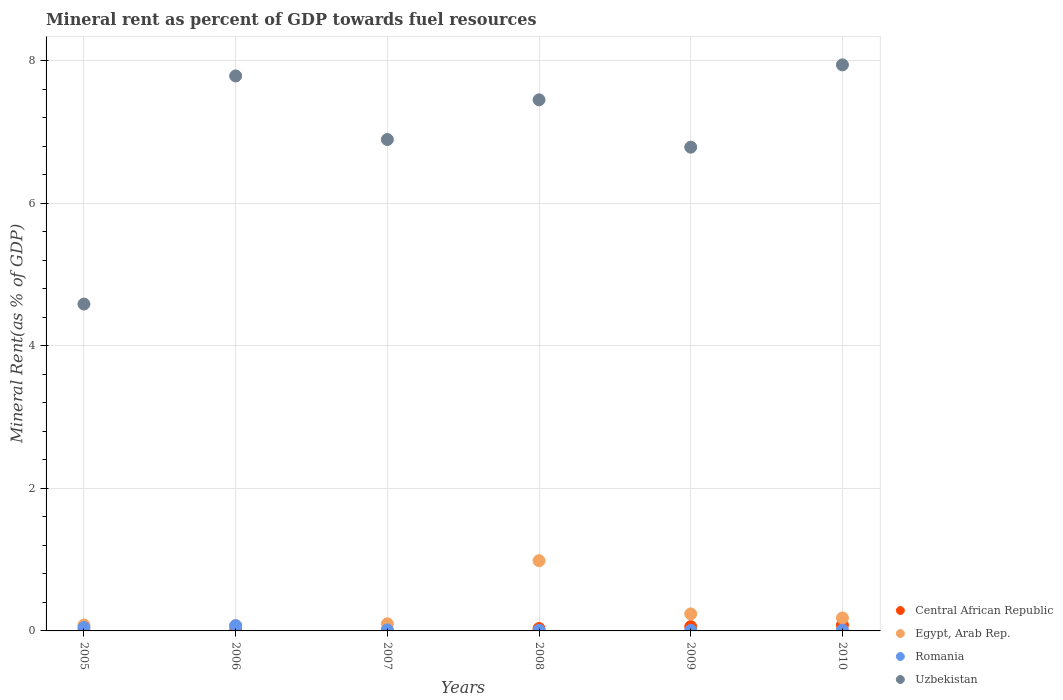How many different coloured dotlines are there?
Provide a short and direct response. 4. What is the mineral rent in Uzbekistan in 2005?
Provide a succinct answer. 4.59. Across all years, what is the maximum mineral rent in Uzbekistan?
Offer a terse response. 7.95. Across all years, what is the minimum mineral rent in Uzbekistan?
Provide a succinct answer. 4.59. In which year was the mineral rent in Central African Republic maximum?
Your answer should be very brief. 2010. In which year was the mineral rent in Central African Republic minimum?
Offer a very short reply. 2005. What is the total mineral rent in Egypt, Arab Rep. in the graph?
Make the answer very short. 1.67. What is the difference between the mineral rent in Egypt, Arab Rep. in 2005 and that in 2009?
Your answer should be compact. -0.16. What is the difference between the mineral rent in Egypt, Arab Rep. in 2005 and the mineral rent in Uzbekistan in 2008?
Offer a terse response. -7.37. What is the average mineral rent in Romania per year?
Offer a terse response. 0.03. In the year 2009, what is the difference between the mineral rent in Romania and mineral rent in Uzbekistan?
Give a very brief answer. -6.78. In how many years, is the mineral rent in Egypt, Arab Rep. greater than 7.6 %?
Your answer should be compact. 0. What is the ratio of the mineral rent in Uzbekistan in 2005 to that in 2009?
Your response must be concise. 0.68. Is the difference between the mineral rent in Romania in 2008 and 2009 greater than the difference between the mineral rent in Uzbekistan in 2008 and 2009?
Offer a terse response. No. What is the difference between the highest and the second highest mineral rent in Central African Republic?
Make the answer very short. 0.02. What is the difference between the highest and the lowest mineral rent in Egypt, Arab Rep.?
Offer a very short reply. 0.91. Is the sum of the mineral rent in Egypt, Arab Rep. in 2007 and 2008 greater than the maximum mineral rent in Uzbekistan across all years?
Give a very brief answer. No. Is it the case that in every year, the sum of the mineral rent in Romania and mineral rent in Uzbekistan  is greater than the mineral rent in Central African Republic?
Offer a terse response. Yes. Does the mineral rent in Central African Republic monotonically increase over the years?
Provide a short and direct response. Yes. Is the mineral rent in Central African Republic strictly greater than the mineral rent in Uzbekistan over the years?
Your answer should be very brief. No. Is the mineral rent in Egypt, Arab Rep. strictly less than the mineral rent in Romania over the years?
Give a very brief answer. No. How many years are there in the graph?
Offer a terse response. 6. What is the difference between two consecutive major ticks on the Y-axis?
Provide a short and direct response. 2. Are the values on the major ticks of Y-axis written in scientific E-notation?
Keep it short and to the point. No. Does the graph contain any zero values?
Provide a short and direct response. No. Does the graph contain grids?
Provide a succinct answer. Yes. Where does the legend appear in the graph?
Your response must be concise. Bottom right. How are the legend labels stacked?
Keep it short and to the point. Vertical. What is the title of the graph?
Keep it short and to the point. Mineral rent as percent of GDP towards fuel resources. Does "Cabo Verde" appear as one of the legend labels in the graph?
Provide a succinct answer. No. What is the label or title of the X-axis?
Your answer should be compact. Years. What is the label or title of the Y-axis?
Your response must be concise. Mineral Rent(as % of GDP). What is the Mineral Rent(as % of GDP) of Central African Republic in 2005?
Provide a short and direct response. 0. What is the Mineral Rent(as % of GDP) of Egypt, Arab Rep. in 2005?
Give a very brief answer. 0.08. What is the Mineral Rent(as % of GDP) of Romania in 2005?
Provide a short and direct response. 0.05. What is the Mineral Rent(as % of GDP) in Uzbekistan in 2005?
Give a very brief answer. 4.59. What is the Mineral Rent(as % of GDP) in Central African Republic in 2006?
Your response must be concise. 0.01. What is the Mineral Rent(as % of GDP) of Egypt, Arab Rep. in 2006?
Make the answer very short. 0.08. What is the Mineral Rent(as % of GDP) in Romania in 2006?
Provide a short and direct response. 0.07. What is the Mineral Rent(as % of GDP) in Uzbekistan in 2006?
Your answer should be very brief. 7.79. What is the Mineral Rent(as % of GDP) of Central African Republic in 2007?
Offer a very short reply. 0.01. What is the Mineral Rent(as % of GDP) of Egypt, Arab Rep. in 2007?
Provide a short and direct response. 0.1. What is the Mineral Rent(as % of GDP) in Romania in 2007?
Make the answer very short. 0.01. What is the Mineral Rent(as % of GDP) of Uzbekistan in 2007?
Offer a very short reply. 6.9. What is the Mineral Rent(as % of GDP) of Central African Republic in 2008?
Your answer should be very brief. 0.03. What is the Mineral Rent(as % of GDP) of Egypt, Arab Rep. in 2008?
Provide a succinct answer. 0.99. What is the Mineral Rent(as % of GDP) in Romania in 2008?
Your answer should be very brief. 0.01. What is the Mineral Rent(as % of GDP) in Uzbekistan in 2008?
Offer a terse response. 7.45. What is the Mineral Rent(as % of GDP) in Central African Republic in 2009?
Your answer should be very brief. 0.06. What is the Mineral Rent(as % of GDP) of Egypt, Arab Rep. in 2009?
Your answer should be very brief. 0.24. What is the Mineral Rent(as % of GDP) of Romania in 2009?
Make the answer very short. 0.01. What is the Mineral Rent(as % of GDP) in Uzbekistan in 2009?
Offer a very short reply. 6.79. What is the Mineral Rent(as % of GDP) in Central African Republic in 2010?
Make the answer very short. 0.08. What is the Mineral Rent(as % of GDP) of Egypt, Arab Rep. in 2010?
Your answer should be compact. 0.18. What is the Mineral Rent(as % of GDP) in Romania in 2010?
Your answer should be compact. 0.01. What is the Mineral Rent(as % of GDP) in Uzbekistan in 2010?
Keep it short and to the point. 7.95. Across all years, what is the maximum Mineral Rent(as % of GDP) of Central African Republic?
Offer a terse response. 0.08. Across all years, what is the maximum Mineral Rent(as % of GDP) in Egypt, Arab Rep.?
Provide a short and direct response. 0.99. Across all years, what is the maximum Mineral Rent(as % of GDP) in Romania?
Your answer should be compact. 0.07. Across all years, what is the maximum Mineral Rent(as % of GDP) of Uzbekistan?
Provide a short and direct response. 7.95. Across all years, what is the minimum Mineral Rent(as % of GDP) in Central African Republic?
Ensure brevity in your answer.  0. Across all years, what is the minimum Mineral Rent(as % of GDP) in Egypt, Arab Rep.?
Your answer should be compact. 0.08. Across all years, what is the minimum Mineral Rent(as % of GDP) in Romania?
Make the answer very short. 0.01. Across all years, what is the minimum Mineral Rent(as % of GDP) of Uzbekistan?
Provide a succinct answer. 4.59. What is the total Mineral Rent(as % of GDP) of Central African Republic in the graph?
Your response must be concise. 0.19. What is the total Mineral Rent(as % of GDP) in Egypt, Arab Rep. in the graph?
Ensure brevity in your answer.  1.67. What is the total Mineral Rent(as % of GDP) in Romania in the graph?
Your response must be concise. 0.16. What is the total Mineral Rent(as % of GDP) of Uzbekistan in the graph?
Make the answer very short. 41.47. What is the difference between the Mineral Rent(as % of GDP) of Central African Republic in 2005 and that in 2006?
Give a very brief answer. -0. What is the difference between the Mineral Rent(as % of GDP) of Egypt, Arab Rep. in 2005 and that in 2006?
Offer a very short reply. 0.01. What is the difference between the Mineral Rent(as % of GDP) in Romania in 2005 and that in 2006?
Provide a succinct answer. -0.03. What is the difference between the Mineral Rent(as % of GDP) of Uzbekistan in 2005 and that in 2006?
Provide a succinct answer. -3.2. What is the difference between the Mineral Rent(as % of GDP) of Central African Republic in 2005 and that in 2007?
Make the answer very short. -0. What is the difference between the Mineral Rent(as % of GDP) in Egypt, Arab Rep. in 2005 and that in 2007?
Make the answer very short. -0.02. What is the difference between the Mineral Rent(as % of GDP) of Romania in 2005 and that in 2007?
Offer a very short reply. 0.03. What is the difference between the Mineral Rent(as % of GDP) in Uzbekistan in 2005 and that in 2007?
Keep it short and to the point. -2.31. What is the difference between the Mineral Rent(as % of GDP) in Central African Republic in 2005 and that in 2008?
Your answer should be very brief. -0.03. What is the difference between the Mineral Rent(as % of GDP) of Egypt, Arab Rep. in 2005 and that in 2008?
Offer a terse response. -0.9. What is the difference between the Mineral Rent(as % of GDP) in Romania in 2005 and that in 2008?
Your answer should be compact. 0.04. What is the difference between the Mineral Rent(as % of GDP) in Uzbekistan in 2005 and that in 2008?
Provide a short and direct response. -2.87. What is the difference between the Mineral Rent(as % of GDP) of Central African Republic in 2005 and that in 2009?
Your response must be concise. -0.06. What is the difference between the Mineral Rent(as % of GDP) of Egypt, Arab Rep. in 2005 and that in 2009?
Your answer should be compact. -0.16. What is the difference between the Mineral Rent(as % of GDP) of Romania in 2005 and that in 2009?
Offer a terse response. 0.04. What is the difference between the Mineral Rent(as % of GDP) in Uzbekistan in 2005 and that in 2009?
Keep it short and to the point. -2.2. What is the difference between the Mineral Rent(as % of GDP) of Central African Republic in 2005 and that in 2010?
Offer a terse response. -0.08. What is the difference between the Mineral Rent(as % of GDP) in Egypt, Arab Rep. in 2005 and that in 2010?
Offer a very short reply. -0.1. What is the difference between the Mineral Rent(as % of GDP) of Romania in 2005 and that in 2010?
Provide a succinct answer. 0.04. What is the difference between the Mineral Rent(as % of GDP) of Uzbekistan in 2005 and that in 2010?
Your response must be concise. -3.36. What is the difference between the Mineral Rent(as % of GDP) of Central African Republic in 2006 and that in 2007?
Make the answer very short. -0. What is the difference between the Mineral Rent(as % of GDP) in Egypt, Arab Rep. in 2006 and that in 2007?
Keep it short and to the point. -0.02. What is the difference between the Mineral Rent(as % of GDP) in Romania in 2006 and that in 2007?
Ensure brevity in your answer.  0.06. What is the difference between the Mineral Rent(as % of GDP) in Uzbekistan in 2006 and that in 2007?
Offer a very short reply. 0.89. What is the difference between the Mineral Rent(as % of GDP) of Central African Republic in 2006 and that in 2008?
Provide a succinct answer. -0.03. What is the difference between the Mineral Rent(as % of GDP) in Egypt, Arab Rep. in 2006 and that in 2008?
Ensure brevity in your answer.  -0.91. What is the difference between the Mineral Rent(as % of GDP) in Romania in 2006 and that in 2008?
Make the answer very short. 0.07. What is the difference between the Mineral Rent(as % of GDP) of Uzbekistan in 2006 and that in 2008?
Your answer should be very brief. 0.34. What is the difference between the Mineral Rent(as % of GDP) in Central African Republic in 2006 and that in 2009?
Give a very brief answer. -0.05. What is the difference between the Mineral Rent(as % of GDP) of Egypt, Arab Rep. in 2006 and that in 2009?
Keep it short and to the point. -0.16. What is the difference between the Mineral Rent(as % of GDP) of Romania in 2006 and that in 2009?
Make the answer very short. 0.07. What is the difference between the Mineral Rent(as % of GDP) in Uzbekistan in 2006 and that in 2009?
Give a very brief answer. 1. What is the difference between the Mineral Rent(as % of GDP) in Central African Republic in 2006 and that in 2010?
Ensure brevity in your answer.  -0.08. What is the difference between the Mineral Rent(as % of GDP) in Egypt, Arab Rep. in 2006 and that in 2010?
Your answer should be compact. -0.11. What is the difference between the Mineral Rent(as % of GDP) of Romania in 2006 and that in 2010?
Offer a terse response. 0.06. What is the difference between the Mineral Rent(as % of GDP) in Uzbekistan in 2006 and that in 2010?
Ensure brevity in your answer.  -0.16. What is the difference between the Mineral Rent(as % of GDP) in Central African Republic in 2007 and that in 2008?
Offer a very short reply. -0.03. What is the difference between the Mineral Rent(as % of GDP) of Egypt, Arab Rep. in 2007 and that in 2008?
Offer a very short reply. -0.89. What is the difference between the Mineral Rent(as % of GDP) in Romania in 2007 and that in 2008?
Provide a short and direct response. 0.01. What is the difference between the Mineral Rent(as % of GDP) in Uzbekistan in 2007 and that in 2008?
Make the answer very short. -0.56. What is the difference between the Mineral Rent(as % of GDP) in Central African Republic in 2007 and that in 2009?
Provide a succinct answer. -0.05. What is the difference between the Mineral Rent(as % of GDP) in Egypt, Arab Rep. in 2007 and that in 2009?
Make the answer very short. -0.14. What is the difference between the Mineral Rent(as % of GDP) of Romania in 2007 and that in 2009?
Provide a succinct answer. 0.01. What is the difference between the Mineral Rent(as % of GDP) of Uzbekistan in 2007 and that in 2009?
Make the answer very short. 0.11. What is the difference between the Mineral Rent(as % of GDP) in Central African Republic in 2007 and that in 2010?
Your answer should be compact. -0.08. What is the difference between the Mineral Rent(as % of GDP) in Egypt, Arab Rep. in 2007 and that in 2010?
Provide a short and direct response. -0.08. What is the difference between the Mineral Rent(as % of GDP) of Romania in 2007 and that in 2010?
Offer a very short reply. 0. What is the difference between the Mineral Rent(as % of GDP) of Uzbekistan in 2007 and that in 2010?
Your answer should be very brief. -1.05. What is the difference between the Mineral Rent(as % of GDP) in Central African Republic in 2008 and that in 2009?
Give a very brief answer. -0.03. What is the difference between the Mineral Rent(as % of GDP) of Egypt, Arab Rep. in 2008 and that in 2009?
Your answer should be very brief. 0.75. What is the difference between the Mineral Rent(as % of GDP) of Romania in 2008 and that in 2009?
Your answer should be very brief. 0. What is the difference between the Mineral Rent(as % of GDP) of Uzbekistan in 2008 and that in 2009?
Keep it short and to the point. 0.66. What is the difference between the Mineral Rent(as % of GDP) of Central African Republic in 2008 and that in 2010?
Provide a short and direct response. -0.05. What is the difference between the Mineral Rent(as % of GDP) of Egypt, Arab Rep. in 2008 and that in 2010?
Your response must be concise. 0.8. What is the difference between the Mineral Rent(as % of GDP) in Romania in 2008 and that in 2010?
Make the answer very short. -0. What is the difference between the Mineral Rent(as % of GDP) of Uzbekistan in 2008 and that in 2010?
Your response must be concise. -0.49. What is the difference between the Mineral Rent(as % of GDP) in Central African Republic in 2009 and that in 2010?
Your response must be concise. -0.02. What is the difference between the Mineral Rent(as % of GDP) in Egypt, Arab Rep. in 2009 and that in 2010?
Keep it short and to the point. 0.06. What is the difference between the Mineral Rent(as % of GDP) of Romania in 2009 and that in 2010?
Provide a short and direct response. -0. What is the difference between the Mineral Rent(as % of GDP) of Uzbekistan in 2009 and that in 2010?
Provide a short and direct response. -1.16. What is the difference between the Mineral Rent(as % of GDP) in Central African Republic in 2005 and the Mineral Rent(as % of GDP) in Egypt, Arab Rep. in 2006?
Offer a very short reply. -0.07. What is the difference between the Mineral Rent(as % of GDP) in Central African Republic in 2005 and the Mineral Rent(as % of GDP) in Romania in 2006?
Your answer should be compact. -0.07. What is the difference between the Mineral Rent(as % of GDP) of Central African Republic in 2005 and the Mineral Rent(as % of GDP) of Uzbekistan in 2006?
Offer a very short reply. -7.79. What is the difference between the Mineral Rent(as % of GDP) in Egypt, Arab Rep. in 2005 and the Mineral Rent(as % of GDP) in Romania in 2006?
Offer a terse response. 0.01. What is the difference between the Mineral Rent(as % of GDP) of Egypt, Arab Rep. in 2005 and the Mineral Rent(as % of GDP) of Uzbekistan in 2006?
Ensure brevity in your answer.  -7.71. What is the difference between the Mineral Rent(as % of GDP) in Romania in 2005 and the Mineral Rent(as % of GDP) in Uzbekistan in 2006?
Make the answer very short. -7.74. What is the difference between the Mineral Rent(as % of GDP) in Central African Republic in 2005 and the Mineral Rent(as % of GDP) in Egypt, Arab Rep. in 2007?
Provide a succinct answer. -0.1. What is the difference between the Mineral Rent(as % of GDP) in Central African Republic in 2005 and the Mineral Rent(as % of GDP) in Romania in 2007?
Ensure brevity in your answer.  -0.01. What is the difference between the Mineral Rent(as % of GDP) of Central African Republic in 2005 and the Mineral Rent(as % of GDP) of Uzbekistan in 2007?
Provide a succinct answer. -6.89. What is the difference between the Mineral Rent(as % of GDP) in Egypt, Arab Rep. in 2005 and the Mineral Rent(as % of GDP) in Romania in 2007?
Provide a short and direct response. 0.07. What is the difference between the Mineral Rent(as % of GDP) in Egypt, Arab Rep. in 2005 and the Mineral Rent(as % of GDP) in Uzbekistan in 2007?
Offer a very short reply. -6.81. What is the difference between the Mineral Rent(as % of GDP) of Romania in 2005 and the Mineral Rent(as % of GDP) of Uzbekistan in 2007?
Keep it short and to the point. -6.85. What is the difference between the Mineral Rent(as % of GDP) of Central African Republic in 2005 and the Mineral Rent(as % of GDP) of Egypt, Arab Rep. in 2008?
Give a very brief answer. -0.98. What is the difference between the Mineral Rent(as % of GDP) of Central African Republic in 2005 and the Mineral Rent(as % of GDP) of Romania in 2008?
Offer a terse response. -0. What is the difference between the Mineral Rent(as % of GDP) of Central African Republic in 2005 and the Mineral Rent(as % of GDP) of Uzbekistan in 2008?
Keep it short and to the point. -7.45. What is the difference between the Mineral Rent(as % of GDP) of Egypt, Arab Rep. in 2005 and the Mineral Rent(as % of GDP) of Romania in 2008?
Give a very brief answer. 0.07. What is the difference between the Mineral Rent(as % of GDP) in Egypt, Arab Rep. in 2005 and the Mineral Rent(as % of GDP) in Uzbekistan in 2008?
Your answer should be compact. -7.37. What is the difference between the Mineral Rent(as % of GDP) of Romania in 2005 and the Mineral Rent(as % of GDP) of Uzbekistan in 2008?
Your answer should be compact. -7.41. What is the difference between the Mineral Rent(as % of GDP) of Central African Republic in 2005 and the Mineral Rent(as % of GDP) of Egypt, Arab Rep. in 2009?
Your answer should be compact. -0.23. What is the difference between the Mineral Rent(as % of GDP) of Central African Republic in 2005 and the Mineral Rent(as % of GDP) of Romania in 2009?
Provide a succinct answer. -0. What is the difference between the Mineral Rent(as % of GDP) in Central African Republic in 2005 and the Mineral Rent(as % of GDP) in Uzbekistan in 2009?
Your response must be concise. -6.79. What is the difference between the Mineral Rent(as % of GDP) in Egypt, Arab Rep. in 2005 and the Mineral Rent(as % of GDP) in Romania in 2009?
Provide a short and direct response. 0.08. What is the difference between the Mineral Rent(as % of GDP) of Egypt, Arab Rep. in 2005 and the Mineral Rent(as % of GDP) of Uzbekistan in 2009?
Make the answer very short. -6.71. What is the difference between the Mineral Rent(as % of GDP) in Romania in 2005 and the Mineral Rent(as % of GDP) in Uzbekistan in 2009?
Offer a very short reply. -6.74. What is the difference between the Mineral Rent(as % of GDP) of Central African Republic in 2005 and the Mineral Rent(as % of GDP) of Egypt, Arab Rep. in 2010?
Give a very brief answer. -0.18. What is the difference between the Mineral Rent(as % of GDP) of Central African Republic in 2005 and the Mineral Rent(as % of GDP) of Romania in 2010?
Provide a succinct answer. -0.01. What is the difference between the Mineral Rent(as % of GDP) of Central African Republic in 2005 and the Mineral Rent(as % of GDP) of Uzbekistan in 2010?
Provide a succinct answer. -7.94. What is the difference between the Mineral Rent(as % of GDP) in Egypt, Arab Rep. in 2005 and the Mineral Rent(as % of GDP) in Romania in 2010?
Your answer should be compact. 0.07. What is the difference between the Mineral Rent(as % of GDP) in Egypt, Arab Rep. in 2005 and the Mineral Rent(as % of GDP) in Uzbekistan in 2010?
Your answer should be very brief. -7.86. What is the difference between the Mineral Rent(as % of GDP) of Romania in 2005 and the Mineral Rent(as % of GDP) of Uzbekistan in 2010?
Your response must be concise. -7.9. What is the difference between the Mineral Rent(as % of GDP) of Central African Republic in 2006 and the Mineral Rent(as % of GDP) of Egypt, Arab Rep. in 2007?
Keep it short and to the point. -0.09. What is the difference between the Mineral Rent(as % of GDP) of Central African Republic in 2006 and the Mineral Rent(as % of GDP) of Romania in 2007?
Your answer should be very brief. -0.01. What is the difference between the Mineral Rent(as % of GDP) in Central African Republic in 2006 and the Mineral Rent(as % of GDP) in Uzbekistan in 2007?
Offer a terse response. -6.89. What is the difference between the Mineral Rent(as % of GDP) in Egypt, Arab Rep. in 2006 and the Mineral Rent(as % of GDP) in Romania in 2007?
Your response must be concise. 0.06. What is the difference between the Mineral Rent(as % of GDP) in Egypt, Arab Rep. in 2006 and the Mineral Rent(as % of GDP) in Uzbekistan in 2007?
Provide a succinct answer. -6.82. What is the difference between the Mineral Rent(as % of GDP) in Romania in 2006 and the Mineral Rent(as % of GDP) in Uzbekistan in 2007?
Give a very brief answer. -6.82. What is the difference between the Mineral Rent(as % of GDP) of Central African Republic in 2006 and the Mineral Rent(as % of GDP) of Egypt, Arab Rep. in 2008?
Give a very brief answer. -0.98. What is the difference between the Mineral Rent(as % of GDP) in Central African Republic in 2006 and the Mineral Rent(as % of GDP) in Romania in 2008?
Provide a succinct answer. -0. What is the difference between the Mineral Rent(as % of GDP) of Central African Republic in 2006 and the Mineral Rent(as % of GDP) of Uzbekistan in 2008?
Provide a succinct answer. -7.45. What is the difference between the Mineral Rent(as % of GDP) of Egypt, Arab Rep. in 2006 and the Mineral Rent(as % of GDP) of Romania in 2008?
Provide a succinct answer. 0.07. What is the difference between the Mineral Rent(as % of GDP) in Egypt, Arab Rep. in 2006 and the Mineral Rent(as % of GDP) in Uzbekistan in 2008?
Your response must be concise. -7.38. What is the difference between the Mineral Rent(as % of GDP) in Romania in 2006 and the Mineral Rent(as % of GDP) in Uzbekistan in 2008?
Offer a terse response. -7.38. What is the difference between the Mineral Rent(as % of GDP) of Central African Republic in 2006 and the Mineral Rent(as % of GDP) of Egypt, Arab Rep. in 2009?
Your answer should be very brief. -0.23. What is the difference between the Mineral Rent(as % of GDP) in Central African Republic in 2006 and the Mineral Rent(as % of GDP) in Romania in 2009?
Give a very brief answer. -0. What is the difference between the Mineral Rent(as % of GDP) of Central African Republic in 2006 and the Mineral Rent(as % of GDP) of Uzbekistan in 2009?
Offer a very short reply. -6.78. What is the difference between the Mineral Rent(as % of GDP) in Egypt, Arab Rep. in 2006 and the Mineral Rent(as % of GDP) in Romania in 2009?
Your response must be concise. 0.07. What is the difference between the Mineral Rent(as % of GDP) of Egypt, Arab Rep. in 2006 and the Mineral Rent(as % of GDP) of Uzbekistan in 2009?
Offer a very short reply. -6.71. What is the difference between the Mineral Rent(as % of GDP) in Romania in 2006 and the Mineral Rent(as % of GDP) in Uzbekistan in 2009?
Offer a terse response. -6.72. What is the difference between the Mineral Rent(as % of GDP) of Central African Republic in 2006 and the Mineral Rent(as % of GDP) of Egypt, Arab Rep. in 2010?
Offer a very short reply. -0.18. What is the difference between the Mineral Rent(as % of GDP) of Central African Republic in 2006 and the Mineral Rent(as % of GDP) of Romania in 2010?
Your response must be concise. -0. What is the difference between the Mineral Rent(as % of GDP) in Central African Republic in 2006 and the Mineral Rent(as % of GDP) in Uzbekistan in 2010?
Your response must be concise. -7.94. What is the difference between the Mineral Rent(as % of GDP) of Egypt, Arab Rep. in 2006 and the Mineral Rent(as % of GDP) of Romania in 2010?
Your answer should be very brief. 0.07. What is the difference between the Mineral Rent(as % of GDP) of Egypt, Arab Rep. in 2006 and the Mineral Rent(as % of GDP) of Uzbekistan in 2010?
Your answer should be very brief. -7.87. What is the difference between the Mineral Rent(as % of GDP) in Romania in 2006 and the Mineral Rent(as % of GDP) in Uzbekistan in 2010?
Give a very brief answer. -7.87. What is the difference between the Mineral Rent(as % of GDP) of Central African Republic in 2007 and the Mineral Rent(as % of GDP) of Egypt, Arab Rep. in 2008?
Offer a very short reply. -0.98. What is the difference between the Mineral Rent(as % of GDP) in Central African Republic in 2007 and the Mineral Rent(as % of GDP) in Romania in 2008?
Provide a succinct answer. -0. What is the difference between the Mineral Rent(as % of GDP) of Central African Republic in 2007 and the Mineral Rent(as % of GDP) of Uzbekistan in 2008?
Provide a short and direct response. -7.45. What is the difference between the Mineral Rent(as % of GDP) of Egypt, Arab Rep. in 2007 and the Mineral Rent(as % of GDP) of Romania in 2008?
Provide a short and direct response. 0.09. What is the difference between the Mineral Rent(as % of GDP) in Egypt, Arab Rep. in 2007 and the Mineral Rent(as % of GDP) in Uzbekistan in 2008?
Ensure brevity in your answer.  -7.35. What is the difference between the Mineral Rent(as % of GDP) in Romania in 2007 and the Mineral Rent(as % of GDP) in Uzbekistan in 2008?
Offer a terse response. -7.44. What is the difference between the Mineral Rent(as % of GDP) of Central African Republic in 2007 and the Mineral Rent(as % of GDP) of Egypt, Arab Rep. in 2009?
Your answer should be compact. -0.23. What is the difference between the Mineral Rent(as % of GDP) in Central African Republic in 2007 and the Mineral Rent(as % of GDP) in Romania in 2009?
Provide a short and direct response. -0. What is the difference between the Mineral Rent(as % of GDP) of Central African Republic in 2007 and the Mineral Rent(as % of GDP) of Uzbekistan in 2009?
Provide a short and direct response. -6.78. What is the difference between the Mineral Rent(as % of GDP) of Egypt, Arab Rep. in 2007 and the Mineral Rent(as % of GDP) of Romania in 2009?
Provide a succinct answer. 0.09. What is the difference between the Mineral Rent(as % of GDP) of Egypt, Arab Rep. in 2007 and the Mineral Rent(as % of GDP) of Uzbekistan in 2009?
Offer a terse response. -6.69. What is the difference between the Mineral Rent(as % of GDP) in Romania in 2007 and the Mineral Rent(as % of GDP) in Uzbekistan in 2009?
Give a very brief answer. -6.78. What is the difference between the Mineral Rent(as % of GDP) of Central African Republic in 2007 and the Mineral Rent(as % of GDP) of Egypt, Arab Rep. in 2010?
Offer a terse response. -0.18. What is the difference between the Mineral Rent(as % of GDP) in Central African Republic in 2007 and the Mineral Rent(as % of GDP) in Romania in 2010?
Make the answer very short. -0. What is the difference between the Mineral Rent(as % of GDP) of Central African Republic in 2007 and the Mineral Rent(as % of GDP) of Uzbekistan in 2010?
Give a very brief answer. -7.94. What is the difference between the Mineral Rent(as % of GDP) of Egypt, Arab Rep. in 2007 and the Mineral Rent(as % of GDP) of Romania in 2010?
Provide a succinct answer. 0.09. What is the difference between the Mineral Rent(as % of GDP) of Egypt, Arab Rep. in 2007 and the Mineral Rent(as % of GDP) of Uzbekistan in 2010?
Offer a very short reply. -7.85. What is the difference between the Mineral Rent(as % of GDP) in Romania in 2007 and the Mineral Rent(as % of GDP) in Uzbekistan in 2010?
Offer a terse response. -7.93. What is the difference between the Mineral Rent(as % of GDP) of Central African Republic in 2008 and the Mineral Rent(as % of GDP) of Egypt, Arab Rep. in 2009?
Your response must be concise. -0.21. What is the difference between the Mineral Rent(as % of GDP) in Central African Republic in 2008 and the Mineral Rent(as % of GDP) in Romania in 2009?
Your response must be concise. 0.03. What is the difference between the Mineral Rent(as % of GDP) in Central African Republic in 2008 and the Mineral Rent(as % of GDP) in Uzbekistan in 2009?
Your answer should be compact. -6.76. What is the difference between the Mineral Rent(as % of GDP) of Egypt, Arab Rep. in 2008 and the Mineral Rent(as % of GDP) of Romania in 2009?
Offer a very short reply. 0.98. What is the difference between the Mineral Rent(as % of GDP) of Egypt, Arab Rep. in 2008 and the Mineral Rent(as % of GDP) of Uzbekistan in 2009?
Give a very brief answer. -5.8. What is the difference between the Mineral Rent(as % of GDP) of Romania in 2008 and the Mineral Rent(as % of GDP) of Uzbekistan in 2009?
Provide a succinct answer. -6.78. What is the difference between the Mineral Rent(as % of GDP) of Central African Republic in 2008 and the Mineral Rent(as % of GDP) of Egypt, Arab Rep. in 2010?
Offer a terse response. -0.15. What is the difference between the Mineral Rent(as % of GDP) in Central African Republic in 2008 and the Mineral Rent(as % of GDP) in Romania in 2010?
Keep it short and to the point. 0.02. What is the difference between the Mineral Rent(as % of GDP) in Central African Republic in 2008 and the Mineral Rent(as % of GDP) in Uzbekistan in 2010?
Your answer should be very brief. -7.91. What is the difference between the Mineral Rent(as % of GDP) of Egypt, Arab Rep. in 2008 and the Mineral Rent(as % of GDP) of Romania in 2010?
Provide a succinct answer. 0.98. What is the difference between the Mineral Rent(as % of GDP) in Egypt, Arab Rep. in 2008 and the Mineral Rent(as % of GDP) in Uzbekistan in 2010?
Your response must be concise. -6.96. What is the difference between the Mineral Rent(as % of GDP) of Romania in 2008 and the Mineral Rent(as % of GDP) of Uzbekistan in 2010?
Give a very brief answer. -7.94. What is the difference between the Mineral Rent(as % of GDP) of Central African Republic in 2009 and the Mineral Rent(as % of GDP) of Egypt, Arab Rep. in 2010?
Your response must be concise. -0.12. What is the difference between the Mineral Rent(as % of GDP) of Central African Republic in 2009 and the Mineral Rent(as % of GDP) of Romania in 2010?
Provide a short and direct response. 0.05. What is the difference between the Mineral Rent(as % of GDP) of Central African Republic in 2009 and the Mineral Rent(as % of GDP) of Uzbekistan in 2010?
Ensure brevity in your answer.  -7.89. What is the difference between the Mineral Rent(as % of GDP) of Egypt, Arab Rep. in 2009 and the Mineral Rent(as % of GDP) of Romania in 2010?
Your answer should be very brief. 0.23. What is the difference between the Mineral Rent(as % of GDP) of Egypt, Arab Rep. in 2009 and the Mineral Rent(as % of GDP) of Uzbekistan in 2010?
Offer a very short reply. -7.71. What is the difference between the Mineral Rent(as % of GDP) of Romania in 2009 and the Mineral Rent(as % of GDP) of Uzbekistan in 2010?
Provide a succinct answer. -7.94. What is the average Mineral Rent(as % of GDP) of Central African Republic per year?
Offer a terse response. 0.03. What is the average Mineral Rent(as % of GDP) of Egypt, Arab Rep. per year?
Ensure brevity in your answer.  0.28. What is the average Mineral Rent(as % of GDP) in Romania per year?
Your answer should be compact. 0.03. What is the average Mineral Rent(as % of GDP) in Uzbekistan per year?
Your answer should be compact. 6.91. In the year 2005, what is the difference between the Mineral Rent(as % of GDP) of Central African Republic and Mineral Rent(as % of GDP) of Egypt, Arab Rep.?
Your answer should be compact. -0.08. In the year 2005, what is the difference between the Mineral Rent(as % of GDP) of Central African Republic and Mineral Rent(as % of GDP) of Romania?
Provide a succinct answer. -0.04. In the year 2005, what is the difference between the Mineral Rent(as % of GDP) in Central African Republic and Mineral Rent(as % of GDP) in Uzbekistan?
Your response must be concise. -4.58. In the year 2005, what is the difference between the Mineral Rent(as % of GDP) of Egypt, Arab Rep. and Mineral Rent(as % of GDP) of Romania?
Provide a succinct answer. 0.04. In the year 2005, what is the difference between the Mineral Rent(as % of GDP) of Egypt, Arab Rep. and Mineral Rent(as % of GDP) of Uzbekistan?
Your answer should be very brief. -4.5. In the year 2005, what is the difference between the Mineral Rent(as % of GDP) of Romania and Mineral Rent(as % of GDP) of Uzbekistan?
Make the answer very short. -4.54. In the year 2006, what is the difference between the Mineral Rent(as % of GDP) of Central African Republic and Mineral Rent(as % of GDP) of Egypt, Arab Rep.?
Your answer should be compact. -0.07. In the year 2006, what is the difference between the Mineral Rent(as % of GDP) of Central African Republic and Mineral Rent(as % of GDP) of Romania?
Your response must be concise. -0.07. In the year 2006, what is the difference between the Mineral Rent(as % of GDP) in Central African Republic and Mineral Rent(as % of GDP) in Uzbekistan?
Provide a succinct answer. -7.78. In the year 2006, what is the difference between the Mineral Rent(as % of GDP) of Egypt, Arab Rep. and Mineral Rent(as % of GDP) of Romania?
Your response must be concise. 0. In the year 2006, what is the difference between the Mineral Rent(as % of GDP) of Egypt, Arab Rep. and Mineral Rent(as % of GDP) of Uzbekistan?
Your answer should be very brief. -7.71. In the year 2006, what is the difference between the Mineral Rent(as % of GDP) in Romania and Mineral Rent(as % of GDP) in Uzbekistan?
Give a very brief answer. -7.72. In the year 2007, what is the difference between the Mineral Rent(as % of GDP) of Central African Republic and Mineral Rent(as % of GDP) of Egypt, Arab Rep.?
Make the answer very short. -0.09. In the year 2007, what is the difference between the Mineral Rent(as % of GDP) in Central African Republic and Mineral Rent(as % of GDP) in Romania?
Offer a terse response. -0.01. In the year 2007, what is the difference between the Mineral Rent(as % of GDP) of Central African Republic and Mineral Rent(as % of GDP) of Uzbekistan?
Ensure brevity in your answer.  -6.89. In the year 2007, what is the difference between the Mineral Rent(as % of GDP) in Egypt, Arab Rep. and Mineral Rent(as % of GDP) in Romania?
Provide a succinct answer. 0.09. In the year 2007, what is the difference between the Mineral Rent(as % of GDP) in Egypt, Arab Rep. and Mineral Rent(as % of GDP) in Uzbekistan?
Ensure brevity in your answer.  -6.8. In the year 2007, what is the difference between the Mineral Rent(as % of GDP) of Romania and Mineral Rent(as % of GDP) of Uzbekistan?
Keep it short and to the point. -6.88. In the year 2008, what is the difference between the Mineral Rent(as % of GDP) of Central African Republic and Mineral Rent(as % of GDP) of Egypt, Arab Rep.?
Ensure brevity in your answer.  -0.95. In the year 2008, what is the difference between the Mineral Rent(as % of GDP) in Central African Republic and Mineral Rent(as % of GDP) in Romania?
Your response must be concise. 0.03. In the year 2008, what is the difference between the Mineral Rent(as % of GDP) of Central African Republic and Mineral Rent(as % of GDP) of Uzbekistan?
Your response must be concise. -7.42. In the year 2008, what is the difference between the Mineral Rent(as % of GDP) of Egypt, Arab Rep. and Mineral Rent(as % of GDP) of Romania?
Your response must be concise. 0.98. In the year 2008, what is the difference between the Mineral Rent(as % of GDP) in Egypt, Arab Rep. and Mineral Rent(as % of GDP) in Uzbekistan?
Offer a very short reply. -6.47. In the year 2008, what is the difference between the Mineral Rent(as % of GDP) in Romania and Mineral Rent(as % of GDP) in Uzbekistan?
Offer a very short reply. -7.45. In the year 2009, what is the difference between the Mineral Rent(as % of GDP) of Central African Republic and Mineral Rent(as % of GDP) of Egypt, Arab Rep.?
Keep it short and to the point. -0.18. In the year 2009, what is the difference between the Mineral Rent(as % of GDP) of Central African Republic and Mineral Rent(as % of GDP) of Romania?
Give a very brief answer. 0.05. In the year 2009, what is the difference between the Mineral Rent(as % of GDP) of Central African Republic and Mineral Rent(as % of GDP) of Uzbekistan?
Offer a very short reply. -6.73. In the year 2009, what is the difference between the Mineral Rent(as % of GDP) of Egypt, Arab Rep. and Mineral Rent(as % of GDP) of Romania?
Give a very brief answer. 0.23. In the year 2009, what is the difference between the Mineral Rent(as % of GDP) in Egypt, Arab Rep. and Mineral Rent(as % of GDP) in Uzbekistan?
Make the answer very short. -6.55. In the year 2009, what is the difference between the Mineral Rent(as % of GDP) of Romania and Mineral Rent(as % of GDP) of Uzbekistan?
Provide a short and direct response. -6.78. In the year 2010, what is the difference between the Mineral Rent(as % of GDP) of Central African Republic and Mineral Rent(as % of GDP) of Egypt, Arab Rep.?
Your response must be concise. -0.1. In the year 2010, what is the difference between the Mineral Rent(as % of GDP) in Central African Republic and Mineral Rent(as % of GDP) in Romania?
Your response must be concise. 0.07. In the year 2010, what is the difference between the Mineral Rent(as % of GDP) of Central African Republic and Mineral Rent(as % of GDP) of Uzbekistan?
Offer a terse response. -7.86. In the year 2010, what is the difference between the Mineral Rent(as % of GDP) of Egypt, Arab Rep. and Mineral Rent(as % of GDP) of Romania?
Make the answer very short. 0.17. In the year 2010, what is the difference between the Mineral Rent(as % of GDP) of Egypt, Arab Rep. and Mineral Rent(as % of GDP) of Uzbekistan?
Offer a very short reply. -7.76. In the year 2010, what is the difference between the Mineral Rent(as % of GDP) in Romania and Mineral Rent(as % of GDP) in Uzbekistan?
Your answer should be very brief. -7.93. What is the ratio of the Mineral Rent(as % of GDP) of Central African Republic in 2005 to that in 2006?
Your answer should be very brief. 0.69. What is the ratio of the Mineral Rent(as % of GDP) of Egypt, Arab Rep. in 2005 to that in 2006?
Keep it short and to the point. 1.1. What is the ratio of the Mineral Rent(as % of GDP) in Romania in 2005 to that in 2006?
Your answer should be very brief. 0.65. What is the ratio of the Mineral Rent(as % of GDP) in Uzbekistan in 2005 to that in 2006?
Provide a succinct answer. 0.59. What is the ratio of the Mineral Rent(as % of GDP) in Central African Republic in 2005 to that in 2007?
Provide a succinct answer. 0.63. What is the ratio of the Mineral Rent(as % of GDP) in Egypt, Arab Rep. in 2005 to that in 2007?
Your response must be concise. 0.83. What is the ratio of the Mineral Rent(as % of GDP) of Romania in 2005 to that in 2007?
Ensure brevity in your answer.  3.34. What is the ratio of the Mineral Rent(as % of GDP) in Uzbekistan in 2005 to that in 2007?
Give a very brief answer. 0.67. What is the ratio of the Mineral Rent(as % of GDP) in Central African Republic in 2005 to that in 2008?
Keep it short and to the point. 0.12. What is the ratio of the Mineral Rent(as % of GDP) in Egypt, Arab Rep. in 2005 to that in 2008?
Offer a very short reply. 0.08. What is the ratio of the Mineral Rent(as % of GDP) of Romania in 2005 to that in 2008?
Make the answer very short. 5.66. What is the ratio of the Mineral Rent(as % of GDP) of Uzbekistan in 2005 to that in 2008?
Provide a short and direct response. 0.62. What is the ratio of the Mineral Rent(as % of GDP) of Central African Republic in 2005 to that in 2009?
Make the answer very short. 0.07. What is the ratio of the Mineral Rent(as % of GDP) of Egypt, Arab Rep. in 2005 to that in 2009?
Provide a short and direct response. 0.35. What is the ratio of the Mineral Rent(as % of GDP) in Romania in 2005 to that in 2009?
Keep it short and to the point. 6.63. What is the ratio of the Mineral Rent(as % of GDP) of Uzbekistan in 2005 to that in 2009?
Give a very brief answer. 0.68. What is the ratio of the Mineral Rent(as % of GDP) in Central African Republic in 2005 to that in 2010?
Ensure brevity in your answer.  0.05. What is the ratio of the Mineral Rent(as % of GDP) of Egypt, Arab Rep. in 2005 to that in 2010?
Ensure brevity in your answer.  0.46. What is the ratio of the Mineral Rent(as % of GDP) in Romania in 2005 to that in 2010?
Make the answer very short. 4.56. What is the ratio of the Mineral Rent(as % of GDP) of Uzbekistan in 2005 to that in 2010?
Offer a terse response. 0.58. What is the ratio of the Mineral Rent(as % of GDP) of Central African Republic in 2006 to that in 2007?
Give a very brief answer. 0.91. What is the ratio of the Mineral Rent(as % of GDP) of Egypt, Arab Rep. in 2006 to that in 2007?
Provide a short and direct response. 0.75. What is the ratio of the Mineral Rent(as % of GDP) in Romania in 2006 to that in 2007?
Ensure brevity in your answer.  5.16. What is the ratio of the Mineral Rent(as % of GDP) in Uzbekistan in 2006 to that in 2007?
Offer a very short reply. 1.13. What is the ratio of the Mineral Rent(as % of GDP) in Central African Republic in 2006 to that in 2008?
Make the answer very short. 0.17. What is the ratio of the Mineral Rent(as % of GDP) in Egypt, Arab Rep. in 2006 to that in 2008?
Keep it short and to the point. 0.08. What is the ratio of the Mineral Rent(as % of GDP) of Romania in 2006 to that in 2008?
Keep it short and to the point. 8.73. What is the ratio of the Mineral Rent(as % of GDP) of Uzbekistan in 2006 to that in 2008?
Offer a very short reply. 1.04. What is the ratio of the Mineral Rent(as % of GDP) in Central African Republic in 2006 to that in 2009?
Give a very brief answer. 0.1. What is the ratio of the Mineral Rent(as % of GDP) in Egypt, Arab Rep. in 2006 to that in 2009?
Keep it short and to the point. 0.32. What is the ratio of the Mineral Rent(as % of GDP) of Romania in 2006 to that in 2009?
Offer a terse response. 10.24. What is the ratio of the Mineral Rent(as % of GDP) of Uzbekistan in 2006 to that in 2009?
Make the answer very short. 1.15. What is the ratio of the Mineral Rent(as % of GDP) in Central African Republic in 2006 to that in 2010?
Keep it short and to the point. 0.07. What is the ratio of the Mineral Rent(as % of GDP) in Egypt, Arab Rep. in 2006 to that in 2010?
Ensure brevity in your answer.  0.41. What is the ratio of the Mineral Rent(as % of GDP) in Romania in 2006 to that in 2010?
Your response must be concise. 7.04. What is the ratio of the Mineral Rent(as % of GDP) in Uzbekistan in 2006 to that in 2010?
Provide a short and direct response. 0.98. What is the ratio of the Mineral Rent(as % of GDP) in Central African Republic in 2007 to that in 2008?
Offer a terse response. 0.19. What is the ratio of the Mineral Rent(as % of GDP) of Egypt, Arab Rep. in 2007 to that in 2008?
Your answer should be compact. 0.1. What is the ratio of the Mineral Rent(as % of GDP) of Romania in 2007 to that in 2008?
Your answer should be compact. 1.69. What is the ratio of the Mineral Rent(as % of GDP) in Uzbekistan in 2007 to that in 2008?
Give a very brief answer. 0.93. What is the ratio of the Mineral Rent(as % of GDP) in Central African Republic in 2007 to that in 2009?
Offer a terse response. 0.11. What is the ratio of the Mineral Rent(as % of GDP) of Egypt, Arab Rep. in 2007 to that in 2009?
Provide a succinct answer. 0.42. What is the ratio of the Mineral Rent(as % of GDP) in Romania in 2007 to that in 2009?
Provide a short and direct response. 1.99. What is the ratio of the Mineral Rent(as % of GDP) of Uzbekistan in 2007 to that in 2009?
Make the answer very short. 1.02. What is the ratio of the Mineral Rent(as % of GDP) of Central African Republic in 2007 to that in 2010?
Offer a very short reply. 0.08. What is the ratio of the Mineral Rent(as % of GDP) in Egypt, Arab Rep. in 2007 to that in 2010?
Your answer should be compact. 0.55. What is the ratio of the Mineral Rent(as % of GDP) of Romania in 2007 to that in 2010?
Offer a terse response. 1.37. What is the ratio of the Mineral Rent(as % of GDP) in Uzbekistan in 2007 to that in 2010?
Provide a short and direct response. 0.87. What is the ratio of the Mineral Rent(as % of GDP) of Central African Republic in 2008 to that in 2009?
Your response must be concise. 0.56. What is the ratio of the Mineral Rent(as % of GDP) in Egypt, Arab Rep. in 2008 to that in 2009?
Offer a terse response. 4.13. What is the ratio of the Mineral Rent(as % of GDP) of Romania in 2008 to that in 2009?
Your answer should be compact. 1.17. What is the ratio of the Mineral Rent(as % of GDP) of Uzbekistan in 2008 to that in 2009?
Give a very brief answer. 1.1. What is the ratio of the Mineral Rent(as % of GDP) of Central African Republic in 2008 to that in 2010?
Keep it short and to the point. 0.41. What is the ratio of the Mineral Rent(as % of GDP) in Egypt, Arab Rep. in 2008 to that in 2010?
Give a very brief answer. 5.42. What is the ratio of the Mineral Rent(as % of GDP) of Romania in 2008 to that in 2010?
Your response must be concise. 0.81. What is the ratio of the Mineral Rent(as % of GDP) in Uzbekistan in 2008 to that in 2010?
Make the answer very short. 0.94. What is the ratio of the Mineral Rent(as % of GDP) of Central African Republic in 2009 to that in 2010?
Make the answer very short. 0.73. What is the ratio of the Mineral Rent(as % of GDP) of Egypt, Arab Rep. in 2009 to that in 2010?
Your answer should be compact. 1.31. What is the ratio of the Mineral Rent(as % of GDP) of Romania in 2009 to that in 2010?
Make the answer very short. 0.69. What is the ratio of the Mineral Rent(as % of GDP) in Uzbekistan in 2009 to that in 2010?
Keep it short and to the point. 0.85. What is the difference between the highest and the second highest Mineral Rent(as % of GDP) in Central African Republic?
Provide a short and direct response. 0.02. What is the difference between the highest and the second highest Mineral Rent(as % of GDP) of Egypt, Arab Rep.?
Give a very brief answer. 0.75. What is the difference between the highest and the second highest Mineral Rent(as % of GDP) of Romania?
Ensure brevity in your answer.  0.03. What is the difference between the highest and the second highest Mineral Rent(as % of GDP) of Uzbekistan?
Your answer should be very brief. 0.16. What is the difference between the highest and the lowest Mineral Rent(as % of GDP) of Central African Republic?
Provide a succinct answer. 0.08. What is the difference between the highest and the lowest Mineral Rent(as % of GDP) of Egypt, Arab Rep.?
Ensure brevity in your answer.  0.91. What is the difference between the highest and the lowest Mineral Rent(as % of GDP) in Romania?
Ensure brevity in your answer.  0.07. What is the difference between the highest and the lowest Mineral Rent(as % of GDP) in Uzbekistan?
Your answer should be compact. 3.36. 